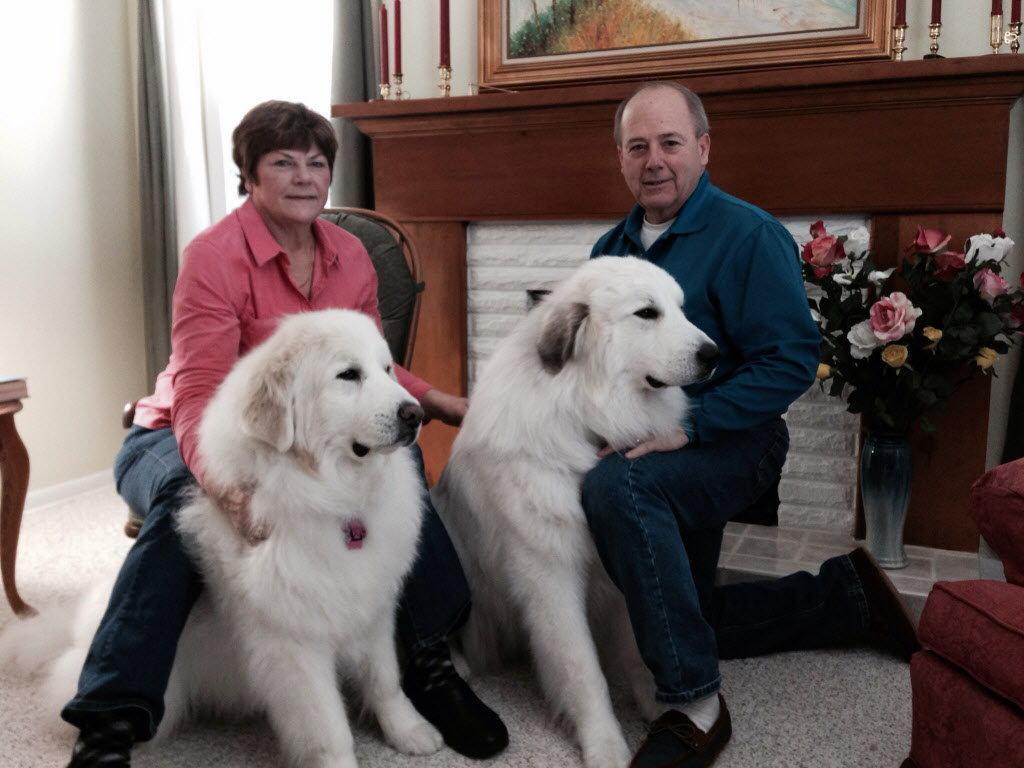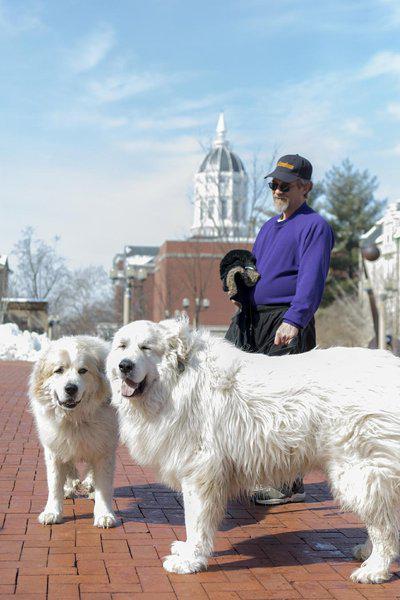The first image is the image on the left, the second image is the image on the right. Considering the images on both sides, is "Each image shows one person in an indoors setting with a large dog." valid? Answer yes or no. No. The first image is the image on the left, the second image is the image on the right. Examine the images to the left and right. Is the description "An image shows exactly one person behind two white dogs." accurate? Answer yes or no. Yes. 